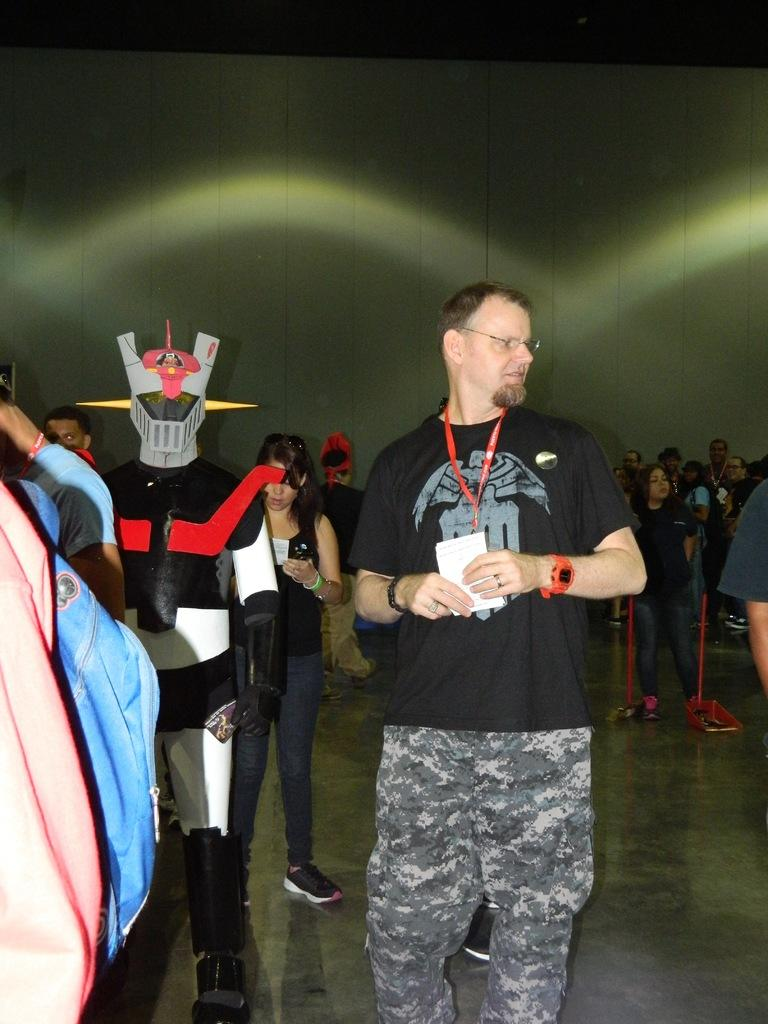What is happening in the image? There are people standing in the image. What is the surface beneath the people's feet? There is a floor visible in the image. What can be seen behind the people? There is a wall in the background of the image. What type of nut is being used as a decoration on the wall in the image? There is no nut present in the image, and the wall does not appear to have any decorations. 